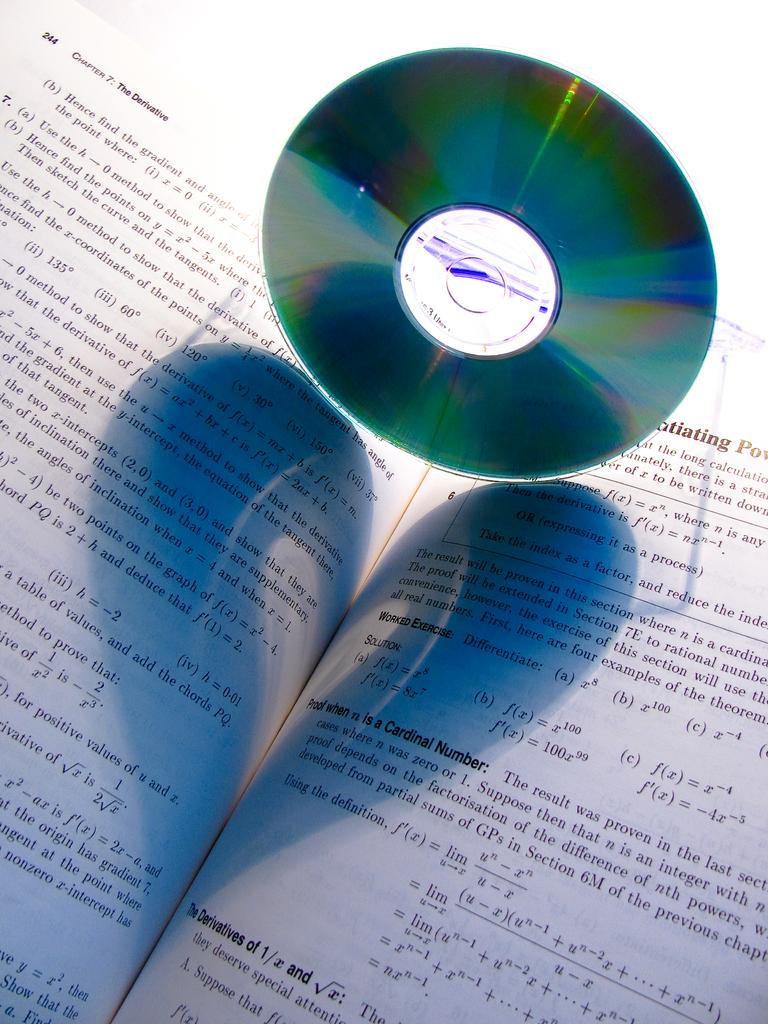<image>
Write a terse but informative summary of the picture. A book is open to a page with a header about cardinal numbers. 